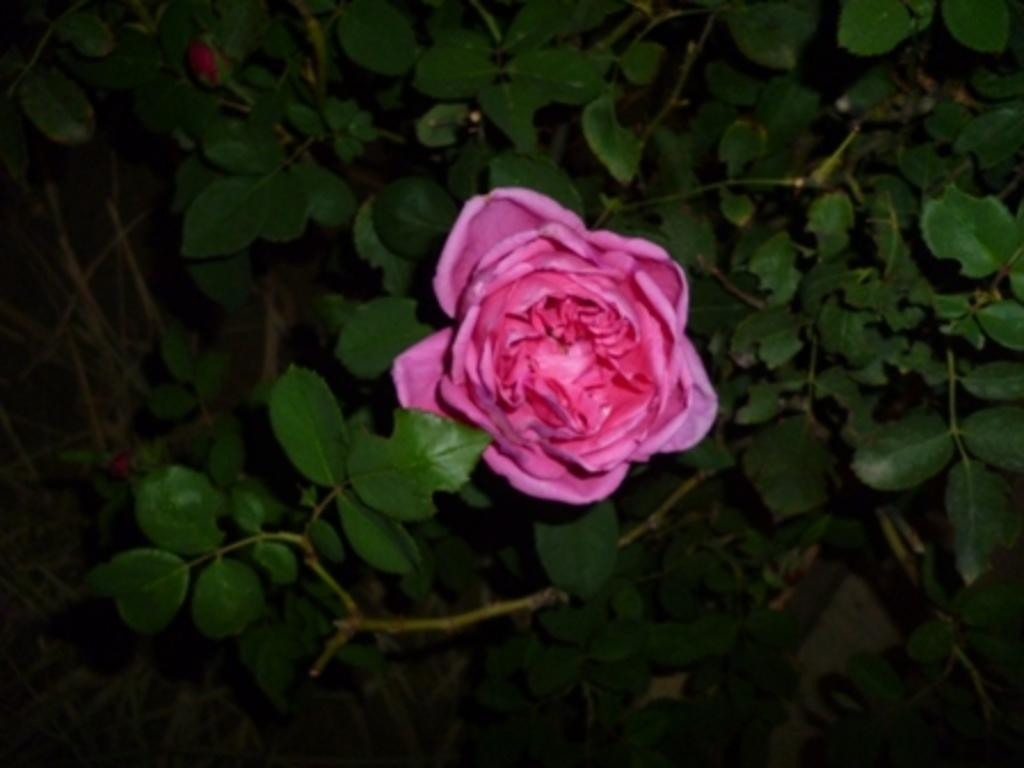What type of flower is in the image? There is a pink rose in the image. Can you describe the stage of the other flower in the image? There is a flower bud in the image. What else can be seen in the image besides the flowers? There are plants around the rose and flower bud. What language is the clover speaking in the image? There is no clover present in the image, and plants do not speak languages. 